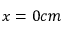<formula> <loc_0><loc_0><loc_500><loc_500>x = 0 c m</formula> 